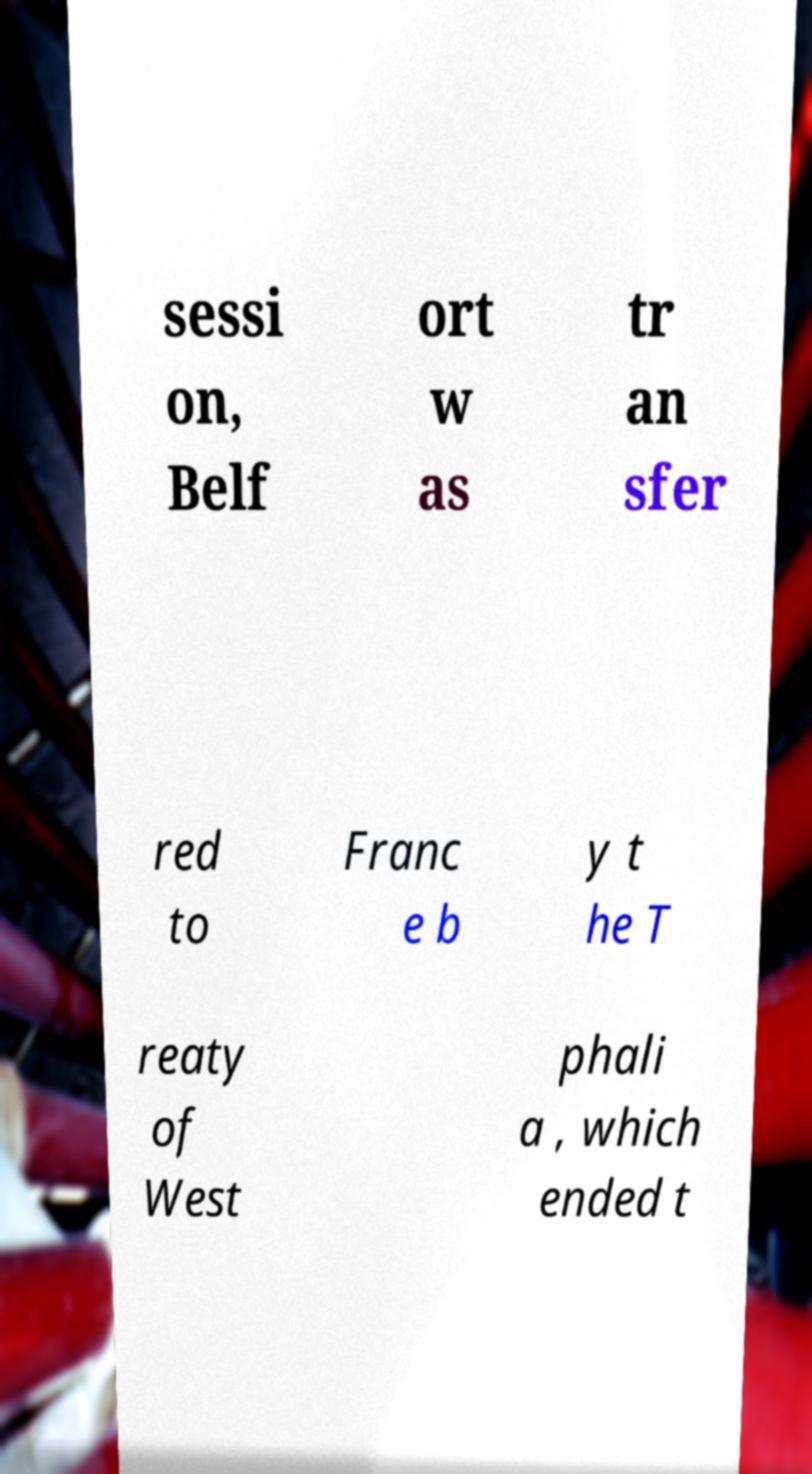What messages or text are displayed in this image? I need them in a readable, typed format. sessi on, Belf ort w as tr an sfer red to Franc e b y t he T reaty of West phali a , which ended t 